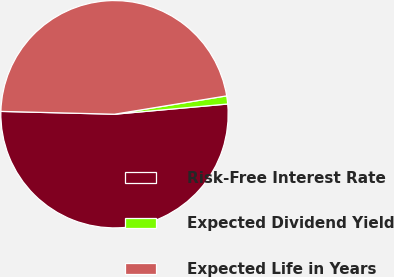Convert chart to OTSL. <chart><loc_0><loc_0><loc_500><loc_500><pie_chart><fcel>Risk-Free Interest Rate<fcel>Expected Dividend Yield<fcel>Expected Life in Years<nl><fcel>51.83%<fcel>1.15%<fcel>47.02%<nl></chart> 